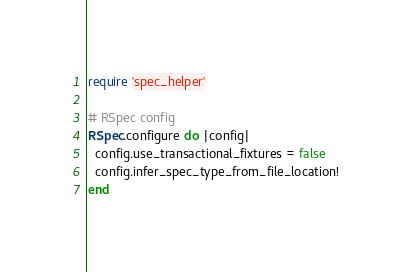<code> <loc_0><loc_0><loc_500><loc_500><_Ruby_>require 'spec_helper'

# RSpec config
RSpec.configure do |config|
  config.use_transactional_fixtures = false
  config.infer_spec_type_from_file_location!
end

</code> 